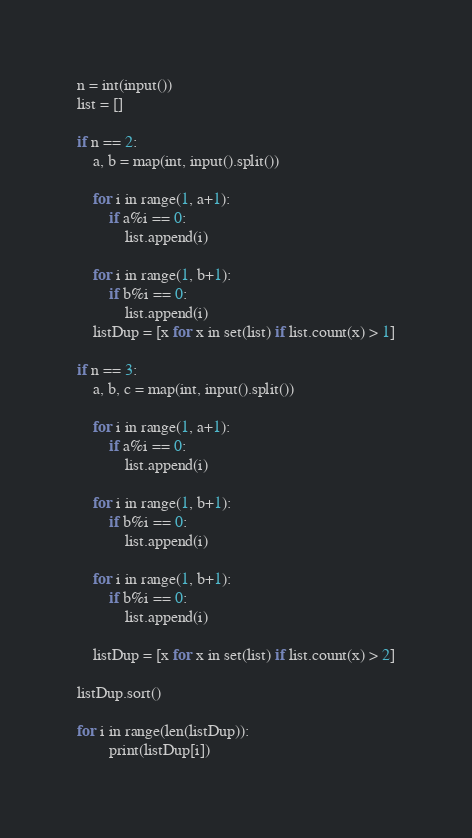Convert code to text. <code><loc_0><loc_0><loc_500><loc_500><_Python_>n = int(input())
list = []

if n == 2:
    a, b = map(int, input().split())
    
    for i in range(1, a+1):
        if a%i == 0:
            list.append(i)
    
    for i in range(1, b+1):
        if b%i == 0:
            list.append(i)
    listDup = [x for x in set(list) if list.count(x) > 1]
    
if n == 3:
    a, b, c = map(int, input().split())
    
    for i in range(1, a+1):
        if a%i == 0:
            list.append(i)
    
    for i in range(1, b+1):
        if b%i == 0:
            list.append(i)
    
    for i in range(1, b+1):
        if b%i == 0:
            list.append(i)
            
    listDup = [x for x in set(list) if list.count(x) > 2]
    
listDup.sort()

for i in range(len(listDup)):
        print(listDup[i])

</code> 